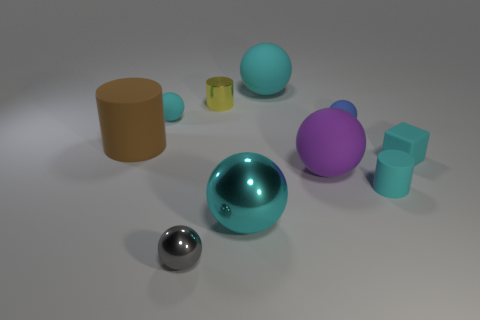What color is the small rubber thing that is in front of the big thing that is on the right side of the large cyan ball that is behind the large cyan metallic object?
Keep it short and to the point. Cyan. Are there an equal number of large balls and tiny blue objects?
Offer a terse response. No. How many blue things are blocks or metallic cylinders?
Provide a succinct answer. 0. How many small shiny objects have the same shape as the big metal thing?
Provide a short and direct response. 1. There is a blue thing that is the same size as the gray sphere; what shape is it?
Give a very brief answer. Sphere. Are there any cyan objects to the right of the small gray object?
Your answer should be very brief. Yes. There is a cyan matte cube that is to the right of the brown matte cylinder; are there any tiny yellow metal cylinders that are to the right of it?
Offer a terse response. No. Are there fewer yellow metallic objects in front of the small cyan rubber ball than small gray metal things that are to the right of the purple ball?
Your response must be concise. No. Are there any other things that have the same size as the shiny cylinder?
Offer a terse response. Yes. The big purple matte object has what shape?
Make the answer very short. Sphere. 